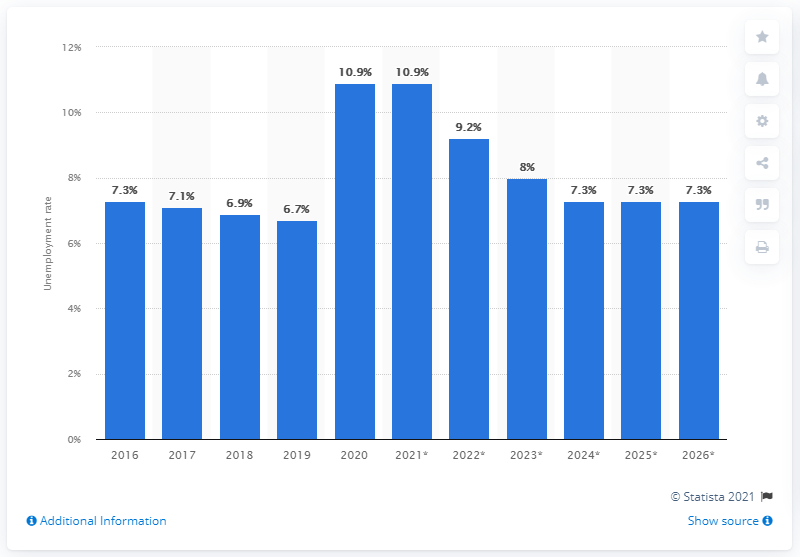Specify some key components in this picture. The unemployment rate in Mauritius was 10.9% in 2020. 